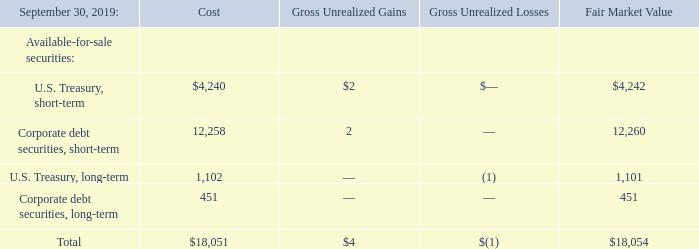5. INVESTMENTS
The Company determines the appropriate designation of investments at the time of purchase and reevaluates such designation as of each balance sheet date. All of the Company’s investments are designated as available-for-sale debt securities. As of September 30, 2019 and 2018, the Company’s short-term investments have maturity dates of less than one year from the balance sheet date. The Company’s long-term investments have maturity dates of greater than one year from the balance sheet date.
Available-for-sale marketable securities are carried at fair value as determined by quoted market prices for identical or similar assets, with unrealized gains and losses, net of taxes, and reported as a separate component of stockholders’ equity. Management reviews the fair value of the portfolio at least monthly and evaluates individual securities with fair value below amortized cost at the balance sheet date. For debt securities, in order to determine whether impairment is other than-temporary, management must conclude whether the Company intends to sell the impaired security and whether it is more likely than not that the Company will be required to sell the security before recovering its amortized cost basis. If management intends to sell an impaired debt security or it is more likely than not the Company will be required to sell the security prior to recovering its amortized cost basis, an other-than-temporary impairment is deemed to have occurred. The amount of an other-than-temporary impairment related to a credit loss, or securities that management intends to sell before recovery, is recognized in earnings. The amount of an other-than-temporary impairment on debt securities related to other factors is recorded consistent with changes in the fair value of all other available for-sale securities as a component of stockholders’ equity in other comprehensive income. No other-than-temporary impairment charges were recognized in the fiscal years ended September 30, 2019, 2018, and 2017. There were no realized gains or losses from the sale of available-for-sale securities during the years ended September 30, 2019 and 2017. The Company recorded a net realized loss from the sale of available-for-sale securities of $49,000 during the year ended September 30, 2018.
The cost of securities sold is based on the specific identification method. Amortization of premiums, accretion of discounts, interest, dividend income, and realized gains and losses are included in investment income.
The following tables summarize investments by type of security as of September 30, 2019 and 2018, respectively(amounts shown in thousands):
How long are the maturity dates of the Company’s short-term investments as of September 2018? Less than one year from the balance sheet date. How does the management review the fair value of the portfolio?  At least monthly and evaluates individual securities with fair value below amortized cost at the balance sheet date. What are the costs of short-term and long-term U.S. Treasury securities, respectively?
Answer scale should be: thousand. $4,240, 1,102. Which securities have the highest fair market value in 2019? 12,260>4,242>1,101>451
Answer: corporate debt securities, short-term. What is the percentage gain of short-term U.S. Treasury securities in 2019?
Answer scale should be: percent. 2/4,242 
Answer: 0.05. What is the ratio (including both short-term and long-term) of the cost from the U.S. Treasury securities to corporate debt securities in 2019? (4,240+1,102)/(12,258+451) 
Answer: 0.42. 